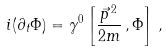Convert formula to latex. <formula><loc_0><loc_0><loc_500><loc_500>i ( \partial _ { t } \Phi ) = \gamma ^ { 0 } \left [ \frac { \vec { p } ^ { \, 2 } } { 2 m } \, , \Phi \right ] \, ,</formula> 